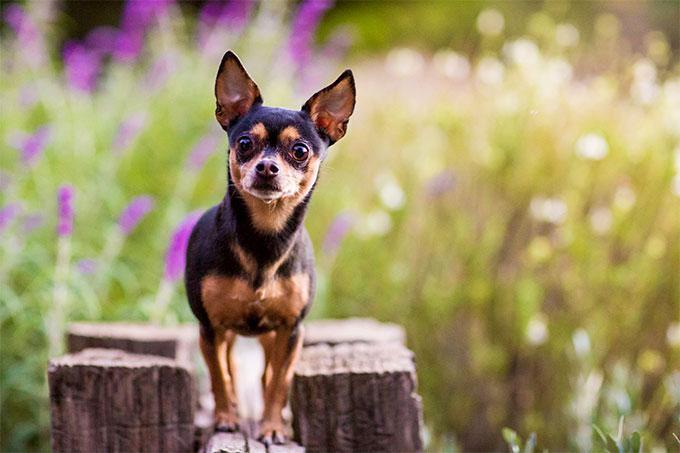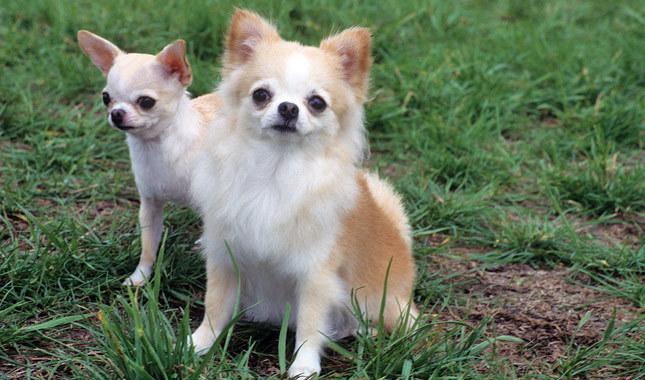The first image is the image on the left, the second image is the image on the right. For the images displayed, is the sentence "One image shows a dog on a leash and the other shows a dog by white fabric." factually correct? Answer yes or no. No. 